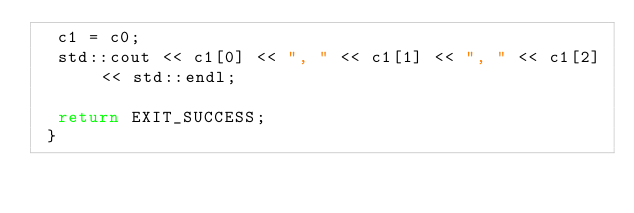Convert code to text. <code><loc_0><loc_0><loc_500><loc_500><_C++_>  c1 = c0;
  std::cout << c1[0] << ", " << c1[1] << ", " << c1[2] << std::endl;

  return EXIT_SUCCESS;
 }
</code> 